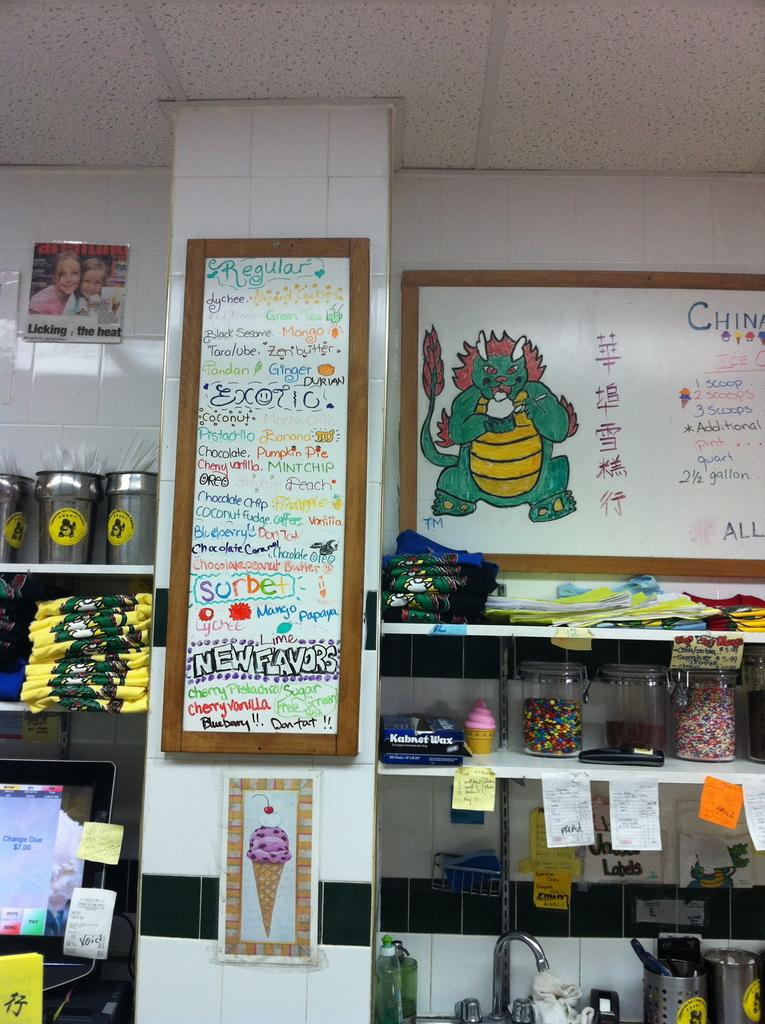What type of structure is present in the image? There are racks in the image. What can be found on the racks? Clothes are present on the racks. What other items can be seen in the image? Papers, a tap, jars, bottles, a screen, and a few unspecified objects are visible in the image. Are there any decorative elements in the image? Yes, photo frames are attached to the wall in the image. What type of substance is being sold at the ticket counter in the image? There is no ticket counter or substance being sold in the image. What type of building is depicted in the image? The image does not show a building; it primarily features racks with clothes and other items. 